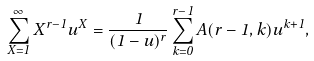Convert formula to latex. <formula><loc_0><loc_0><loc_500><loc_500>\sum _ { X = 1 } ^ { \infty } X ^ { r - 1 } u ^ { X } = \frac { 1 } { ( 1 - u ) ^ { r } } \sum _ { k = 0 } ^ { r - 1 } A ( r - 1 , k ) u ^ { k + 1 } ,</formula> 